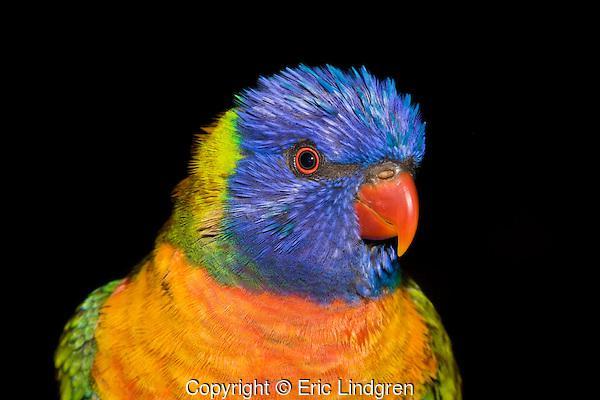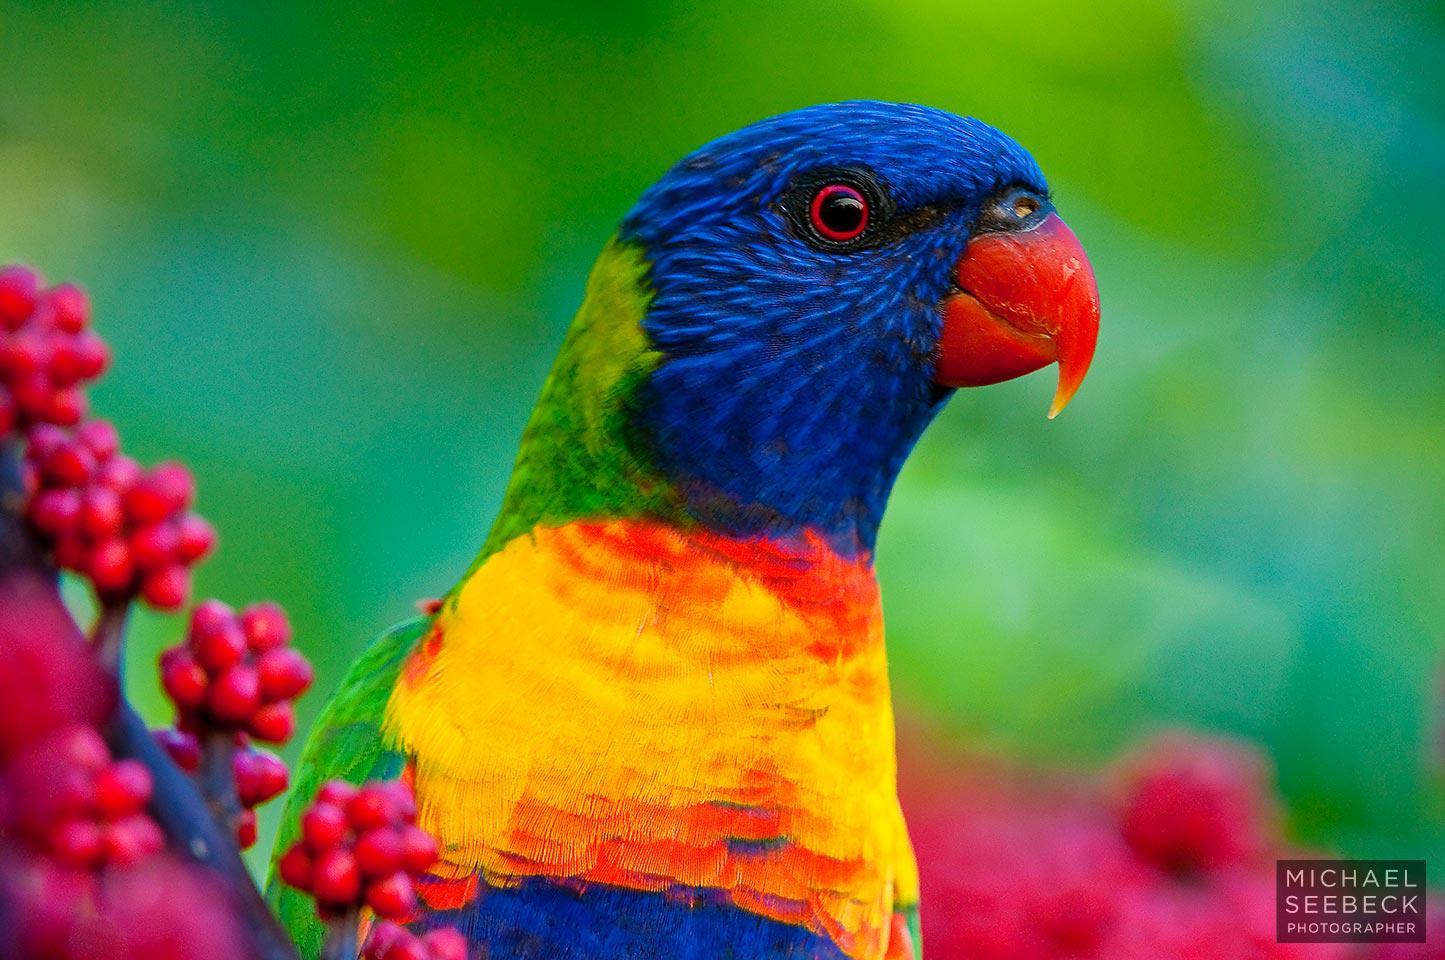The first image is the image on the left, the second image is the image on the right. Evaluate the accuracy of this statement regarding the images: "Four colorful birds are perched outside.". Is it true? Answer yes or no. No. The first image is the image on the left, the second image is the image on the right. Evaluate the accuracy of this statement regarding the images: "Each image contains one pair of multicolor parrots.". Is it true? Answer yes or no. No. 